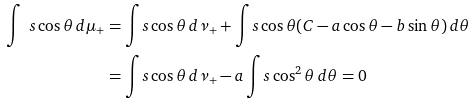Convert formula to latex. <formula><loc_0><loc_0><loc_500><loc_500>\int _ { \ } s \cos \theta \, d \mu _ { + } & = \int _ { \ } s \cos \theta \, d \nu _ { + } + \int _ { \ } s \cos \theta ( C - a \cos \theta - b \sin \theta ) \, d \theta \\ & = \int _ { \ } s \cos \theta \, d \nu _ { + } - a \int _ { \ } s \cos ^ { 2 } \theta \, d \theta = 0</formula> 